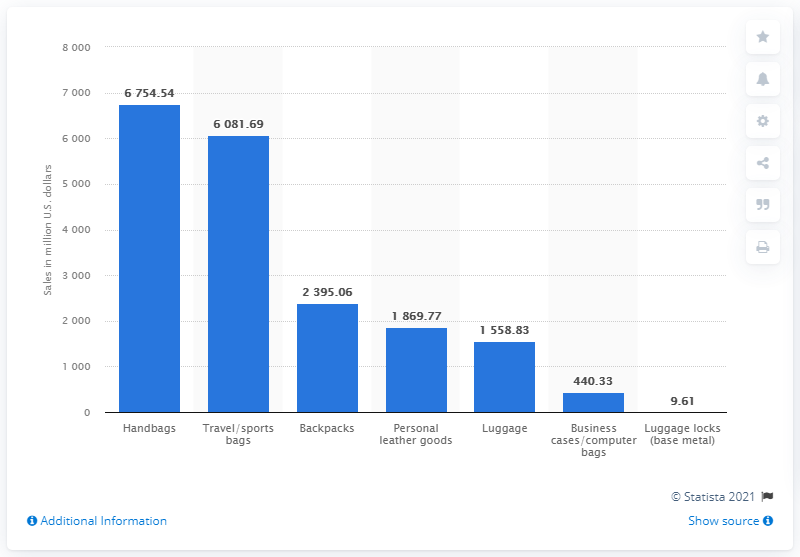Draw attention to some important aspects in this diagram. The second lowest bar value in the blue bar is 440.33. The sum of the first and last bar in the chart is 6,764.15. In 2020, the retail sales of travel and sports bags in the United States reached a total of 6081.69 million dollars. 